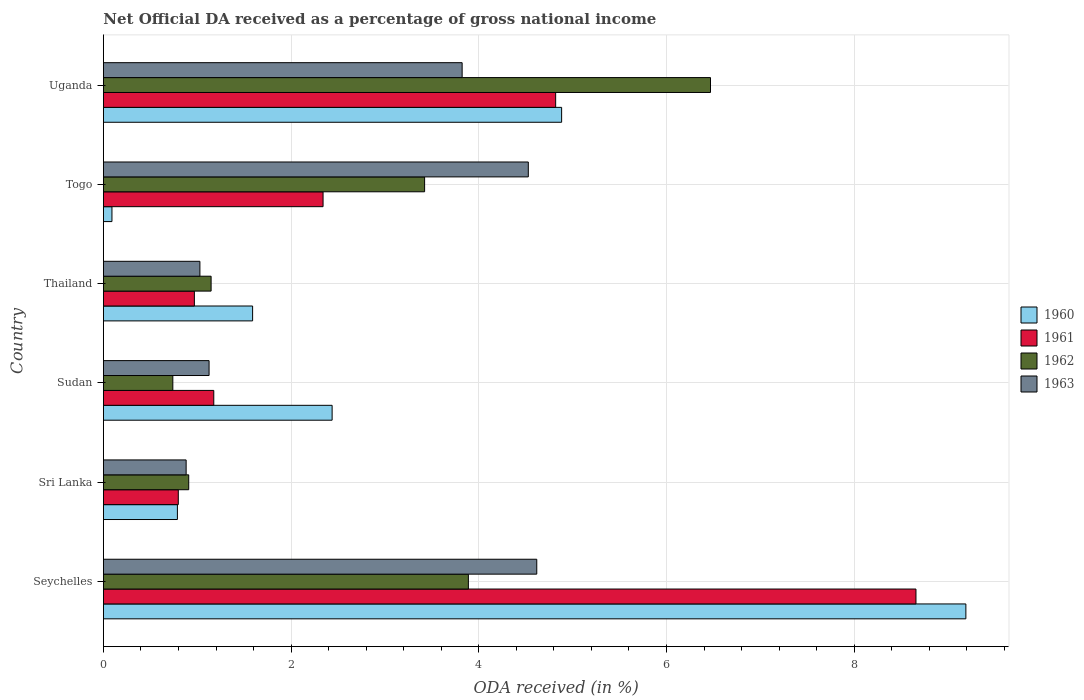Are the number of bars per tick equal to the number of legend labels?
Give a very brief answer. Yes. Are the number of bars on each tick of the Y-axis equal?
Provide a succinct answer. Yes. What is the label of the 2nd group of bars from the top?
Provide a short and direct response. Togo. What is the net official DA received in 1961 in Sri Lanka?
Your answer should be very brief. 0.8. Across all countries, what is the maximum net official DA received in 1960?
Offer a terse response. 9.19. Across all countries, what is the minimum net official DA received in 1960?
Your answer should be very brief. 0.09. In which country was the net official DA received in 1960 maximum?
Make the answer very short. Seychelles. In which country was the net official DA received in 1961 minimum?
Your answer should be very brief. Sri Lanka. What is the total net official DA received in 1962 in the graph?
Your response must be concise. 16.58. What is the difference between the net official DA received in 1961 in Togo and that in Uganda?
Give a very brief answer. -2.48. What is the difference between the net official DA received in 1962 in Sudan and the net official DA received in 1960 in Seychelles?
Your response must be concise. -8.45. What is the average net official DA received in 1960 per country?
Give a very brief answer. 3.16. What is the difference between the net official DA received in 1960 and net official DA received in 1963 in Seychelles?
Make the answer very short. 4.57. What is the ratio of the net official DA received in 1960 in Sudan to that in Thailand?
Ensure brevity in your answer.  1.53. What is the difference between the highest and the second highest net official DA received in 1962?
Keep it short and to the point. 2.58. What is the difference between the highest and the lowest net official DA received in 1963?
Offer a terse response. 3.74. Is the sum of the net official DA received in 1962 in Seychelles and Uganda greater than the maximum net official DA received in 1963 across all countries?
Offer a terse response. Yes. Is it the case that in every country, the sum of the net official DA received in 1962 and net official DA received in 1961 is greater than the sum of net official DA received in 1963 and net official DA received in 1960?
Offer a terse response. No. What does the 4th bar from the top in Seychelles represents?
Provide a succinct answer. 1960. What does the 2nd bar from the bottom in Sudan represents?
Your answer should be very brief. 1961. How many bars are there?
Your answer should be compact. 24. How many countries are there in the graph?
Your response must be concise. 6. What is the difference between two consecutive major ticks on the X-axis?
Offer a terse response. 2. Are the values on the major ticks of X-axis written in scientific E-notation?
Give a very brief answer. No. What is the title of the graph?
Offer a terse response. Net Official DA received as a percentage of gross national income. Does "2011" appear as one of the legend labels in the graph?
Provide a short and direct response. No. What is the label or title of the X-axis?
Your response must be concise. ODA received (in %). What is the label or title of the Y-axis?
Provide a succinct answer. Country. What is the ODA received (in %) of 1960 in Seychelles?
Give a very brief answer. 9.19. What is the ODA received (in %) of 1961 in Seychelles?
Your answer should be compact. 8.66. What is the ODA received (in %) in 1962 in Seychelles?
Ensure brevity in your answer.  3.89. What is the ODA received (in %) of 1963 in Seychelles?
Offer a very short reply. 4.62. What is the ODA received (in %) of 1960 in Sri Lanka?
Offer a very short reply. 0.79. What is the ODA received (in %) in 1961 in Sri Lanka?
Your response must be concise. 0.8. What is the ODA received (in %) in 1962 in Sri Lanka?
Provide a succinct answer. 0.91. What is the ODA received (in %) in 1963 in Sri Lanka?
Keep it short and to the point. 0.88. What is the ODA received (in %) in 1960 in Sudan?
Make the answer very short. 2.44. What is the ODA received (in %) in 1961 in Sudan?
Your response must be concise. 1.18. What is the ODA received (in %) in 1962 in Sudan?
Your response must be concise. 0.74. What is the ODA received (in %) of 1963 in Sudan?
Provide a short and direct response. 1.13. What is the ODA received (in %) in 1960 in Thailand?
Ensure brevity in your answer.  1.59. What is the ODA received (in %) in 1961 in Thailand?
Your answer should be very brief. 0.97. What is the ODA received (in %) in 1962 in Thailand?
Your response must be concise. 1.15. What is the ODA received (in %) in 1963 in Thailand?
Give a very brief answer. 1.03. What is the ODA received (in %) in 1960 in Togo?
Your response must be concise. 0.09. What is the ODA received (in %) in 1961 in Togo?
Ensure brevity in your answer.  2.34. What is the ODA received (in %) in 1962 in Togo?
Provide a short and direct response. 3.42. What is the ODA received (in %) in 1963 in Togo?
Your answer should be compact. 4.53. What is the ODA received (in %) of 1960 in Uganda?
Keep it short and to the point. 4.88. What is the ODA received (in %) in 1961 in Uganda?
Make the answer very short. 4.82. What is the ODA received (in %) of 1962 in Uganda?
Keep it short and to the point. 6.47. What is the ODA received (in %) in 1963 in Uganda?
Your answer should be very brief. 3.82. Across all countries, what is the maximum ODA received (in %) in 1960?
Your response must be concise. 9.19. Across all countries, what is the maximum ODA received (in %) of 1961?
Provide a short and direct response. 8.66. Across all countries, what is the maximum ODA received (in %) in 1962?
Your response must be concise. 6.47. Across all countries, what is the maximum ODA received (in %) in 1963?
Your answer should be compact. 4.62. Across all countries, what is the minimum ODA received (in %) of 1960?
Ensure brevity in your answer.  0.09. Across all countries, what is the minimum ODA received (in %) of 1961?
Your answer should be very brief. 0.8. Across all countries, what is the minimum ODA received (in %) of 1962?
Give a very brief answer. 0.74. Across all countries, what is the minimum ODA received (in %) in 1963?
Ensure brevity in your answer.  0.88. What is the total ODA received (in %) of 1960 in the graph?
Provide a short and direct response. 18.98. What is the total ODA received (in %) in 1961 in the graph?
Offer a terse response. 18.76. What is the total ODA received (in %) of 1962 in the graph?
Keep it short and to the point. 16.58. What is the total ODA received (in %) of 1963 in the graph?
Provide a short and direct response. 16. What is the difference between the ODA received (in %) in 1960 in Seychelles and that in Sri Lanka?
Make the answer very short. 8.4. What is the difference between the ODA received (in %) in 1961 in Seychelles and that in Sri Lanka?
Keep it short and to the point. 7.86. What is the difference between the ODA received (in %) in 1962 in Seychelles and that in Sri Lanka?
Keep it short and to the point. 2.98. What is the difference between the ODA received (in %) of 1963 in Seychelles and that in Sri Lanka?
Offer a very short reply. 3.74. What is the difference between the ODA received (in %) of 1960 in Seychelles and that in Sudan?
Your response must be concise. 6.75. What is the difference between the ODA received (in %) in 1961 in Seychelles and that in Sudan?
Offer a terse response. 7.48. What is the difference between the ODA received (in %) of 1962 in Seychelles and that in Sudan?
Your answer should be compact. 3.15. What is the difference between the ODA received (in %) in 1963 in Seychelles and that in Sudan?
Ensure brevity in your answer.  3.49. What is the difference between the ODA received (in %) of 1960 in Seychelles and that in Thailand?
Keep it short and to the point. 7.6. What is the difference between the ODA received (in %) in 1961 in Seychelles and that in Thailand?
Give a very brief answer. 7.69. What is the difference between the ODA received (in %) in 1962 in Seychelles and that in Thailand?
Provide a succinct answer. 2.74. What is the difference between the ODA received (in %) in 1963 in Seychelles and that in Thailand?
Your answer should be compact. 3.59. What is the difference between the ODA received (in %) in 1960 in Seychelles and that in Togo?
Your response must be concise. 9.1. What is the difference between the ODA received (in %) in 1961 in Seychelles and that in Togo?
Ensure brevity in your answer.  6.32. What is the difference between the ODA received (in %) of 1962 in Seychelles and that in Togo?
Give a very brief answer. 0.47. What is the difference between the ODA received (in %) of 1963 in Seychelles and that in Togo?
Ensure brevity in your answer.  0.09. What is the difference between the ODA received (in %) of 1960 in Seychelles and that in Uganda?
Keep it short and to the point. 4.31. What is the difference between the ODA received (in %) of 1961 in Seychelles and that in Uganda?
Offer a very short reply. 3.84. What is the difference between the ODA received (in %) of 1962 in Seychelles and that in Uganda?
Provide a short and direct response. -2.58. What is the difference between the ODA received (in %) of 1963 in Seychelles and that in Uganda?
Offer a terse response. 0.8. What is the difference between the ODA received (in %) of 1960 in Sri Lanka and that in Sudan?
Ensure brevity in your answer.  -1.65. What is the difference between the ODA received (in %) of 1961 in Sri Lanka and that in Sudan?
Your answer should be compact. -0.38. What is the difference between the ODA received (in %) in 1962 in Sri Lanka and that in Sudan?
Offer a terse response. 0.17. What is the difference between the ODA received (in %) of 1963 in Sri Lanka and that in Sudan?
Ensure brevity in your answer.  -0.24. What is the difference between the ODA received (in %) of 1960 in Sri Lanka and that in Thailand?
Make the answer very short. -0.8. What is the difference between the ODA received (in %) in 1961 in Sri Lanka and that in Thailand?
Keep it short and to the point. -0.17. What is the difference between the ODA received (in %) of 1962 in Sri Lanka and that in Thailand?
Make the answer very short. -0.24. What is the difference between the ODA received (in %) in 1963 in Sri Lanka and that in Thailand?
Your answer should be compact. -0.15. What is the difference between the ODA received (in %) of 1960 in Sri Lanka and that in Togo?
Ensure brevity in your answer.  0.7. What is the difference between the ODA received (in %) in 1961 in Sri Lanka and that in Togo?
Provide a succinct answer. -1.54. What is the difference between the ODA received (in %) in 1962 in Sri Lanka and that in Togo?
Keep it short and to the point. -2.51. What is the difference between the ODA received (in %) in 1963 in Sri Lanka and that in Togo?
Make the answer very short. -3.65. What is the difference between the ODA received (in %) of 1960 in Sri Lanka and that in Uganda?
Offer a terse response. -4.09. What is the difference between the ODA received (in %) in 1961 in Sri Lanka and that in Uganda?
Offer a very short reply. -4.02. What is the difference between the ODA received (in %) of 1962 in Sri Lanka and that in Uganda?
Provide a succinct answer. -5.56. What is the difference between the ODA received (in %) in 1963 in Sri Lanka and that in Uganda?
Your response must be concise. -2.94. What is the difference between the ODA received (in %) of 1960 in Sudan and that in Thailand?
Your response must be concise. 0.85. What is the difference between the ODA received (in %) of 1961 in Sudan and that in Thailand?
Offer a very short reply. 0.21. What is the difference between the ODA received (in %) of 1962 in Sudan and that in Thailand?
Give a very brief answer. -0.41. What is the difference between the ODA received (in %) of 1963 in Sudan and that in Thailand?
Offer a very short reply. 0.1. What is the difference between the ODA received (in %) in 1960 in Sudan and that in Togo?
Your answer should be compact. 2.35. What is the difference between the ODA received (in %) in 1961 in Sudan and that in Togo?
Provide a succinct answer. -1.16. What is the difference between the ODA received (in %) in 1962 in Sudan and that in Togo?
Give a very brief answer. -2.68. What is the difference between the ODA received (in %) of 1963 in Sudan and that in Togo?
Your answer should be compact. -3.4. What is the difference between the ODA received (in %) in 1960 in Sudan and that in Uganda?
Offer a very short reply. -2.45. What is the difference between the ODA received (in %) in 1961 in Sudan and that in Uganda?
Keep it short and to the point. -3.64. What is the difference between the ODA received (in %) of 1962 in Sudan and that in Uganda?
Your response must be concise. -5.73. What is the difference between the ODA received (in %) of 1963 in Sudan and that in Uganda?
Offer a very short reply. -2.7. What is the difference between the ODA received (in %) in 1960 in Thailand and that in Togo?
Your answer should be compact. 1.5. What is the difference between the ODA received (in %) of 1961 in Thailand and that in Togo?
Keep it short and to the point. -1.37. What is the difference between the ODA received (in %) of 1962 in Thailand and that in Togo?
Offer a terse response. -2.27. What is the difference between the ODA received (in %) in 1963 in Thailand and that in Togo?
Keep it short and to the point. -3.5. What is the difference between the ODA received (in %) of 1960 in Thailand and that in Uganda?
Offer a very short reply. -3.29. What is the difference between the ODA received (in %) of 1961 in Thailand and that in Uganda?
Provide a succinct answer. -3.85. What is the difference between the ODA received (in %) of 1962 in Thailand and that in Uganda?
Ensure brevity in your answer.  -5.32. What is the difference between the ODA received (in %) of 1963 in Thailand and that in Uganda?
Offer a terse response. -2.79. What is the difference between the ODA received (in %) in 1960 in Togo and that in Uganda?
Your answer should be very brief. -4.79. What is the difference between the ODA received (in %) of 1961 in Togo and that in Uganda?
Keep it short and to the point. -2.48. What is the difference between the ODA received (in %) of 1962 in Togo and that in Uganda?
Ensure brevity in your answer.  -3.05. What is the difference between the ODA received (in %) of 1963 in Togo and that in Uganda?
Your answer should be compact. 0.7. What is the difference between the ODA received (in %) in 1960 in Seychelles and the ODA received (in %) in 1961 in Sri Lanka?
Ensure brevity in your answer.  8.39. What is the difference between the ODA received (in %) in 1960 in Seychelles and the ODA received (in %) in 1962 in Sri Lanka?
Ensure brevity in your answer.  8.28. What is the difference between the ODA received (in %) in 1960 in Seychelles and the ODA received (in %) in 1963 in Sri Lanka?
Offer a very short reply. 8.31. What is the difference between the ODA received (in %) in 1961 in Seychelles and the ODA received (in %) in 1962 in Sri Lanka?
Provide a succinct answer. 7.75. What is the difference between the ODA received (in %) of 1961 in Seychelles and the ODA received (in %) of 1963 in Sri Lanka?
Provide a succinct answer. 7.78. What is the difference between the ODA received (in %) in 1962 in Seychelles and the ODA received (in %) in 1963 in Sri Lanka?
Your answer should be very brief. 3.01. What is the difference between the ODA received (in %) of 1960 in Seychelles and the ODA received (in %) of 1961 in Sudan?
Give a very brief answer. 8.01. What is the difference between the ODA received (in %) in 1960 in Seychelles and the ODA received (in %) in 1962 in Sudan?
Your answer should be compact. 8.45. What is the difference between the ODA received (in %) of 1960 in Seychelles and the ODA received (in %) of 1963 in Sudan?
Your answer should be very brief. 8.06. What is the difference between the ODA received (in %) of 1961 in Seychelles and the ODA received (in %) of 1962 in Sudan?
Keep it short and to the point. 7.92. What is the difference between the ODA received (in %) of 1961 in Seychelles and the ODA received (in %) of 1963 in Sudan?
Make the answer very short. 7.53. What is the difference between the ODA received (in %) of 1962 in Seychelles and the ODA received (in %) of 1963 in Sudan?
Provide a succinct answer. 2.76. What is the difference between the ODA received (in %) of 1960 in Seychelles and the ODA received (in %) of 1961 in Thailand?
Offer a terse response. 8.22. What is the difference between the ODA received (in %) of 1960 in Seychelles and the ODA received (in %) of 1962 in Thailand?
Your answer should be very brief. 8.04. What is the difference between the ODA received (in %) of 1960 in Seychelles and the ODA received (in %) of 1963 in Thailand?
Your response must be concise. 8.16. What is the difference between the ODA received (in %) in 1961 in Seychelles and the ODA received (in %) in 1962 in Thailand?
Keep it short and to the point. 7.51. What is the difference between the ODA received (in %) of 1961 in Seychelles and the ODA received (in %) of 1963 in Thailand?
Offer a very short reply. 7.63. What is the difference between the ODA received (in %) in 1962 in Seychelles and the ODA received (in %) in 1963 in Thailand?
Ensure brevity in your answer.  2.86. What is the difference between the ODA received (in %) in 1960 in Seychelles and the ODA received (in %) in 1961 in Togo?
Offer a terse response. 6.85. What is the difference between the ODA received (in %) of 1960 in Seychelles and the ODA received (in %) of 1962 in Togo?
Your answer should be compact. 5.77. What is the difference between the ODA received (in %) of 1960 in Seychelles and the ODA received (in %) of 1963 in Togo?
Ensure brevity in your answer.  4.66. What is the difference between the ODA received (in %) of 1961 in Seychelles and the ODA received (in %) of 1962 in Togo?
Keep it short and to the point. 5.24. What is the difference between the ODA received (in %) of 1961 in Seychelles and the ODA received (in %) of 1963 in Togo?
Provide a short and direct response. 4.13. What is the difference between the ODA received (in %) in 1962 in Seychelles and the ODA received (in %) in 1963 in Togo?
Offer a very short reply. -0.64. What is the difference between the ODA received (in %) in 1960 in Seychelles and the ODA received (in %) in 1961 in Uganda?
Keep it short and to the point. 4.37. What is the difference between the ODA received (in %) of 1960 in Seychelles and the ODA received (in %) of 1962 in Uganda?
Provide a succinct answer. 2.72. What is the difference between the ODA received (in %) of 1960 in Seychelles and the ODA received (in %) of 1963 in Uganda?
Provide a succinct answer. 5.37. What is the difference between the ODA received (in %) in 1961 in Seychelles and the ODA received (in %) in 1962 in Uganda?
Your response must be concise. 2.19. What is the difference between the ODA received (in %) in 1961 in Seychelles and the ODA received (in %) in 1963 in Uganda?
Ensure brevity in your answer.  4.84. What is the difference between the ODA received (in %) in 1962 in Seychelles and the ODA received (in %) in 1963 in Uganda?
Your answer should be very brief. 0.07. What is the difference between the ODA received (in %) in 1960 in Sri Lanka and the ODA received (in %) in 1961 in Sudan?
Offer a very short reply. -0.39. What is the difference between the ODA received (in %) of 1960 in Sri Lanka and the ODA received (in %) of 1962 in Sudan?
Make the answer very short. 0.05. What is the difference between the ODA received (in %) in 1960 in Sri Lanka and the ODA received (in %) in 1963 in Sudan?
Your answer should be compact. -0.34. What is the difference between the ODA received (in %) of 1961 in Sri Lanka and the ODA received (in %) of 1962 in Sudan?
Keep it short and to the point. 0.06. What is the difference between the ODA received (in %) of 1961 in Sri Lanka and the ODA received (in %) of 1963 in Sudan?
Offer a very short reply. -0.33. What is the difference between the ODA received (in %) of 1962 in Sri Lanka and the ODA received (in %) of 1963 in Sudan?
Provide a short and direct response. -0.22. What is the difference between the ODA received (in %) of 1960 in Sri Lanka and the ODA received (in %) of 1961 in Thailand?
Your response must be concise. -0.18. What is the difference between the ODA received (in %) in 1960 in Sri Lanka and the ODA received (in %) in 1962 in Thailand?
Offer a very short reply. -0.36. What is the difference between the ODA received (in %) in 1960 in Sri Lanka and the ODA received (in %) in 1963 in Thailand?
Your answer should be compact. -0.24. What is the difference between the ODA received (in %) of 1961 in Sri Lanka and the ODA received (in %) of 1962 in Thailand?
Provide a succinct answer. -0.35. What is the difference between the ODA received (in %) in 1961 in Sri Lanka and the ODA received (in %) in 1963 in Thailand?
Offer a very short reply. -0.23. What is the difference between the ODA received (in %) in 1962 in Sri Lanka and the ODA received (in %) in 1963 in Thailand?
Ensure brevity in your answer.  -0.12. What is the difference between the ODA received (in %) of 1960 in Sri Lanka and the ODA received (in %) of 1961 in Togo?
Offer a terse response. -1.55. What is the difference between the ODA received (in %) of 1960 in Sri Lanka and the ODA received (in %) of 1962 in Togo?
Ensure brevity in your answer.  -2.63. What is the difference between the ODA received (in %) of 1960 in Sri Lanka and the ODA received (in %) of 1963 in Togo?
Keep it short and to the point. -3.74. What is the difference between the ODA received (in %) in 1961 in Sri Lanka and the ODA received (in %) in 1962 in Togo?
Offer a very short reply. -2.62. What is the difference between the ODA received (in %) of 1961 in Sri Lanka and the ODA received (in %) of 1963 in Togo?
Your response must be concise. -3.73. What is the difference between the ODA received (in %) of 1962 in Sri Lanka and the ODA received (in %) of 1963 in Togo?
Your answer should be very brief. -3.62. What is the difference between the ODA received (in %) of 1960 in Sri Lanka and the ODA received (in %) of 1961 in Uganda?
Keep it short and to the point. -4.03. What is the difference between the ODA received (in %) of 1960 in Sri Lanka and the ODA received (in %) of 1962 in Uganda?
Your response must be concise. -5.68. What is the difference between the ODA received (in %) in 1960 in Sri Lanka and the ODA received (in %) in 1963 in Uganda?
Offer a terse response. -3.03. What is the difference between the ODA received (in %) of 1961 in Sri Lanka and the ODA received (in %) of 1962 in Uganda?
Provide a succinct answer. -5.67. What is the difference between the ODA received (in %) in 1961 in Sri Lanka and the ODA received (in %) in 1963 in Uganda?
Make the answer very short. -3.02. What is the difference between the ODA received (in %) in 1962 in Sri Lanka and the ODA received (in %) in 1963 in Uganda?
Provide a short and direct response. -2.91. What is the difference between the ODA received (in %) of 1960 in Sudan and the ODA received (in %) of 1961 in Thailand?
Make the answer very short. 1.47. What is the difference between the ODA received (in %) of 1960 in Sudan and the ODA received (in %) of 1962 in Thailand?
Make the answer very short. 1.29. What is the difference between the ODA received (in %) in 1960 in Sudan and the ODA received (in %) in 1963 in Thailand?
Keep it short and to the point. 1.41. What is the difference between the ODA received (in %) of 1961 in Sudan and the ODA received (in %) of 1962 in Thailand?
Offer a terse response. 0.03. What is the difference between the ODA received (in %) in 1961 in Sudan and the ODA received (in %) in 1963 in Thailand?
Give a very brief answer. 0.15. What is the difference between the ODA received (in %) in 1962 in Sudan and the ODA received (in %) in 1963 in Thailand?
Your answer should be compact. -0.29. What is the difference between the ODA received (in %) of 1960 in Sudan and the ODA received (in %) of 1961 in Togo?
Your answer should be very brief. 0.1. What is the difference between the ODA received (in %) of 1960 in Sudan and the ODA received (in %) of 1962 in Togo?
Your answer should be compact. -0.99. What is the difference between the ODA received (in %) in 1960 in Sudan and the ODA received (in %) in 1963 in Togo?
Give a very brief answer. -2.09. What is the difference between the ODA received (in %) of 1961 in Sudan and the ODA received (in %) of 1962 in Togo?
Your answer should be very brief. -2.25. What is the difference between the ODA received (in %) in 1961 in Sudan and the ODA received (in %) in 1963 in Togo?
Provide a short and direct response. -3.35. What is the difference between the ODA received (in %) of 1962 in Sudan and the ODA received (in %) of 1963 in Togo?
Offer a very short reply. -3.79. What is the difference between the ODA received (in %) in 1960 in Sudan and the ODA received (in %) in 1961 in Uganda?
Your answer should be very brief. -2.38. What is the difference between the ODA received (in %) of 1960 in Sudan and the ODA received (in %) of 1962 in Uganda?
Keep it short and to the point. -4.03. What is the difference between the ODA received (in %) in 1960 in Sudan and the ODA received (in %) in 1963 in Uganda?
Give a very brief answer. -1.39. What is the difference between the ODA received (in %) in 1961 in Sudan and the ODA received (in %) in 1962 in Uganda?
Your answer should be compact. -5.29. What is the difference between the ODA received (in %) of 1961 in Sudan and the ODA received (in %) of 1963 in Uganda?
Give a very brief answer. -2.65. What is the difference between the ODA received (in %) in 1962 in Sudan and the ODA received (in %) in 1963 in Uganda?
Provide a short and direct response. -3.08. What is the difference between the ODA received (in %) in 1960 in Thailand and the ODA received (in %) in 1961 in Togo?
Keep it short and to the point. -0.75. What is the difference between the ODA received (in %) in 1960 in Thailand and the ODA received (in %) in 1962 in Togo?
Offer a terse response. -1.83. What is the difference between the ODA received (in %) of 1960 in Thailand and the ODA received (in %) of 1963 in Togo?
Keep it short and to the point. -2.94. What is the difference between the ODA received (in %) in 1961 in Thailand and the ODA received (in %) in 1962 in Togo?
Offer a very short reply. -2.45. What is the difference between the ODA received (in %) in 1961 in Thailand and the ODA received (in %) in 1963 in Togo?
Offer a very short reply. -3.56. What is the difference between the ODA received (in %) of 1962 in Thailand and the ODA received (in %) of 1963 in Togo?
Keep it short and to the point. -3.38. What is the difference between the ODA received (in %) in 1960 in Thailand and the ODA received (in %) in 1961 in Uganda?
Keep it short and to the point. -3.23. What is the difference between the ODA received (in %) in 1960 in Thailand and the ODA received (in %) in 1962 in Uganda?
Offer a very short reply. -4.88. What is the difference between the ODA received (in %) of 1960 in Thailand and the ODA received (in %) of 1963 in Uganda?
Provide a short and direct response. -2.23. What is the difference between the ODA received (in %) in 1961 in Thailand and the ODA received (in %) in 1962 in Uganda?
Ensure brevity in your answer.  -5.5. What is the difference between the ODA received (in %) in 1961 in Thailand and the ODA received (in %) in 1963 in Uganda?
Ensure brevity in your answer.  -2.85. What is the difference between the ODA received (in %) of 1962 in Thailand and the ODA received (in %) of 1963 in Uganda?
Make the answer very short. -2.67. What is the difference between the ODA received (in %) of 1960 in Togo and the ODA received (in %) of 1961 in Uganda?
Give a very brief answer. -4.73. What is the difference between the ODA received (in %) of 1960 in Togo and the ODA received (in %) of 1962 in Uganda?
Offer a terse response. -6.38. What is the difference between the ODA received (in %) of 1960 in Togo and the ODA received (in %) of 1963 in Uganda?
Ensure brevity in your answer.  -3.73. What is the difference between the ODA received (in %) of 1961 in Togo and the ODA received (in %) of 1962 in Uganda?
Ensure brevity in your answer.  -4.13. What is the difference between the ODA received (in %) in 1961 in Togo and the ODA received (in %) in 1963 in Uganda?
Provide a short and direct response. -1.48. What is the difference between the ODA received (in %) in 1962 in Togo and the ODA received (in %) in 1963 in Uganda?
Ensure brevity in your answer.  -0.4. What is the average ODA received (in %) of 1960 per country?
Offer a very short reply. 3.16. What is the average ODA received (in %) in 1961 per country?
Make the answer very short. 3.13. What is the average ODA received (in %) in 1962 per country?
Keep it short and to the point. 2.76. What is the average ODA received (in %) of 1963 per country?
Provide a succinct answer. 2.67. What is the difference between the ODA received (in %) of 1960 and ODA received (in %) of 1961 in Seychelles?
Make the answer very short. 0.53. What is the difference between the ODA received (in %) in 1960 and ODA received (in %) in 1962 in Seychelles?
Ensure brevity in your answer.  5.3. What is the difference between the ODA received (in %) of 1960 and ODA received (in %) of 1963 in Seychelles?
Your response must be concise. 4.57. What is the difference between the ODA received (in %) in 1961 and ODA received (in %) in 1962 in Seychelles?
Your response must be concise. 4.77. What is the difference between the ODA received (in %) of 1961 and ODA received (in %) of 1963 in Seychelles?
Give a very brief answer. 4.04. What is the difference between the ODA received (in %) of 1962 and ODA received (in %) of 1963 in Seychelles?
Make the answer very short. -0.73. What is the difference between the ODA received (in %) in 1960 and ODA received (in %) in 1961 in Sri Lanka?
Provide a short and direct response. -0.01. What is the difference between the ODA received (in %) of 1960 and ODA received (in %) of 1962 in Sri Lanka?
Your response must be concise. -0.12. What is the difference between the ODA received (in %) in 1960 and ODA received (in %) in 1963 in Sri Lanka?
Keep it short and to the point. -0.09. What is the difference between the ODA received (in %) in 1961 and ODA received (in %) in 1962 in Sri Lanka?
Your answer should be very brief. -0.11. What is the difference between the ODA received (in %) in 1961 and ODA received (in %) in 1963 in Sri Lanka?
Offer a terse response. -0.08. What is the difference between the ODA received (in %) in 1962 and ODA received (in %) in 1963 in Sri Lanka?
Ensure brevity in your answer.  0.03. What is the difference between the ODA received (in %) in 1960 and ODA received (in %) in 1961 in Sudan?
Your answer should be compact. 1.26. What is the difference between the ODA received (in %) in 1960 and ODA received (in %) in 1962 in Sudan?
Keep it short and to the point. 1.7. What is the difference between the ODA received (in %) of 1960 and ODA received (in %) of 1963 in Sudan?
Your response must be concise. 1.31. What is the difference between the ODA received (in %) of 1961 and ODA received (in %) of 1962 in Sudan?
Make the answer very short. 0.44. What is the difference between the ODA received (in %) in 1961 and ODA received (in %) in 1963 in Sudan?
Your response must be concise. 0.05. What is the difference between the ODA received (in %) in 1962 and ODA received (in %) in 1963 in Sudan?
Your response must be concise. -0.39. What is the difference between the ODA received (in %) in 1960 and ODA received (in %) in 1961 in Thailand?
Give a very brief answer. 0.62. What is the difference between the ODA received (in %) in 1960 and ODA received (in %) in 1962 in Thailand?
Ensure brevity in your answer.  0.44. What is the difference between the ODA received (in %) of 1960 and ODA received (in %) of 1963 in Thailand?
Provide a succinct answer. 0.56. What is the difference between the ODA received (in %) in 1961 and ODA received (in %) in 1962 in Thailand?
Provide a succinct answer. -0.18. What is the difference between the ODA received (in %) of 1961 and ODA received (in %) of 1963 in Thailand?
Give a very brief answer. -0.06. What is the difference between the ODA received (in %) of 1962 and ODA received (in %) of 1963 in Thailand?
Provide a short and direct response. 0.12. What is the difference between the ODA received (in %) of 1960 and ODA received (in %) of 1961 in Togo?
Your answer should be compact. -2.25. What is the difference between the ODA received (in %) in 1960 and ODA received (in %) in 1962 in Togo?
Your answer should be compact. -3.33. What is the difference between the ODA received (in %) of 1960 and ODA received (in %) of 1963 in Togo?
Your answer should be compact. -4.44. What is the difference between the ODA received (in %) of 1961 and ODA received (in %) of 1962 in Togo?
Ensure brevity in your answer.  -1.08. What is the difference between the ODA received (in %) of 1961 and ODA received (in %) of 1963 in Togo?
Offer a very short reply. -2.19. What is the difference between the ODA received (in %) of 1962 and ODA received (in %) of 1963 in Togo?
Offer a terse response. -1.1. What is the difference between the ODA received (in %) in 1960 and ODA received (in %) in 1961 in Uganda?
Offer a terse response. 0.06. What is the difference between the ODA received (in %) of 1960 and ODA received (in %) of 1962 in Uganda?
Make the answer very short. -1.59. What is the difference between the ODA received (in %) of 1960 and ODA received (in %) of 1963 in Uganda?
Offer a terse response. 1.06. What is the difference between the ODA received (in %) in 1961 and ODA received (in %) in 1962 in Uganda?
Offer a terse response. -1.65. What is the difference between the ODA received (in %) in 1961 and ODA received (in %) in 1963 in Uganda?
Provide a succinct answer. 1. What is the difference between the ODA received (in %) of 1962 and ODA received (in %) of 1963 in Uganda?
Give a very brief answer. 2.65. What is the ratio of the ODA received (in %) of 1960 in Seychelles to that in Sri Lanka?
Offer a terse response. 11.65. What is the ratio of the ODA received (in %) of 1961 in Seychelles to that in Sri Lanka?
Keep it short and to the point. 10.85. What is the ratio of the ODA received (in %) in 1962 in Seychelles to that in Sri Lanka?
Your answer should be compact. 4.28. What is the ratio of the ODA received (in %) in 1963 in Seychelles to that in Sri Lanka?
Make the answer very short. 5.24. What is the ratio of the ODA received (in %) in 1960 in Seychelles to that in Sudan?
Make the answer very short. 3.77. What is the ratio of the ODA received (in %) of 1961 in Seychelles to that in Sudan?
Make the answer very short. 7.36. What is the ratio of the ODA received (in %) of 1962 in Seychelles to that in Sudan?
Provide a short and direct response. 5.26. What is the ratio of the ODA received (in %) in 1963 in Seychelles to that in Sudan?
Your answer should be very brief. 4.1. What is the ratio of the ODA received (in %) of 1960 in Seychelles to that in Thailand?
Provide a succinct answer. 5.78. What is the ratio of the ODA received (in %) in 1961 in Seychelles to that in Thailand?
Offer a terse response. 8.93. What is the ratio of the ODA received (in %) in 1962 in Seychelles to that in Thailand?
Give a very brief answer. 3.39. What is the ratio of the ODA received (in %) in 1963 in Seychelles to that in Thailand?
Keep it short and to the point. 4.49. What is the ratio of the ODA received (in %) of 1960 in Seychelles to that in Togo?
Make the answer very short. 100.8. What is the ratio of the ODA received (in %) in 1961 in Seychelles to that in Togo?
Offer a very short reply. 3.7. What is the ratio of the ODA received (in %) in 1962 in Seychelles to that in Togo?
Give a very brief answer. 1.14. What is the ratio of the ODA received (in %) of 1963 in Seychelles to that in Togo?
Your response must be concise. 1.02. What is the ratio of the ODA received (in %) of 1960 in Seychelles to that in Uganda?
Make the answer very short. 1.88. What is the ratio of the ODA received (in %) of 1961 in Seychelles to that in Uganda?
Offer a terse response. 1.8. What is the ratio of the ODA received (in %) in 1962 in Seychelles to that in Uganda?
Your answer should be very brief. 0.6. What is the ratio of the ODA received (in %) of 1963 in Seychelles to that in Uganda?
Offer a terse response. 1.21. What is the ratio of the ODA received (in %) of 1960 in Sri Lanka to that in Sudan?
Your answer should be compact. 0.32. What is the ratio of the ODA received (in %) in 1961 in Sri Lanka to that in Sudan?
Give a very brief answer. 0.68. What is the ratio of the ODA received (in %) in 1962 in Sri Lanka to that in Sudan?
Your answer should be compact. 1.23. What is the ratio of the ODA received (in %) in 1963 in Sri Lanka to that in Sudan?
Give a very brief answer. 0.78. What is the ratio of the ODA received (in %) in 1960 in Sri Lanka to that in Thailand?
Make the answer very short. 0.5. What is the ratio of the ODA received (in %) of 1961 in Sri Lanka to that in Thailand?
Offer a very short reply. 0.82. What is the ratio of the ODA received (in %) in 1962 in Sri Lanka to that in Thailand?
Provide a succinct answer. 0.79. What is the ratio of the ODA received (in %) of 1963 in Sri Lanka to that in Thailand?
Give a very brief answer. 0.86. What is the ratio of the ODA received (in %) of 1960 in Sri Lanka to that in Togo?
Your answer should be very brief. 8.65. What is the ratio of the ODA received (in %) of 1961 in Sri Lanka to that in Togo?
Your answer should be very brief. 0.34. What is the ratio of the ODA received (in %) in 1962 in Sri Lanka to that in Togo?
Your answer should be compact. 0.27. What is the ratio of the ODA received (in %) in 1963 in Sri Lanka to that in Togo?
Offer a terse response. 0.19. What is the ratio of the ODA received (in %) in 1960 in Sri Lanka to that in Uganda?
Your answer should be very brief. 0.16. What is the ratio of the ODA received (in %) in 1961 in Sri Lanka to that in Uganda?
Give a very brief answer. 0.17. What is the ratio of the ODA received (in %) in 1962 in Sri Lanka to that in Uganda?
Offer a terse response. 0.14. What is the ratio of the ODA received (in %) in 1963 in Sri Lanka to that in Uganda?
Make the answer very short. 0.23. What is the ratio of the ODA received (in %) of 1960 in Sudan to that in Thailand?
Provide a short and direct response. 1.53. What is the ratio of the ODA received (in %) in 1961 in Sudan to that in Thailand?
Provide a succinct answer. 1.21. What is the ratio of the ODA received (in %) of 1962 in Sudan to that in Thailand?
Offer a terse response. 0.64. What is the ratio of the ODA received (in %) of 1963 in Sudan to that in Thailand?
Offer a very short reply. 1.1. What is the ratio of the ODA received (in %) of 1960 in Sudan to that in Togo?
Your answer should be very brief. 26.73. What is the ratio of the ODA received (in %) in 1961 in Sudan to that in Togo?
Make the answer very short. 0.5. What is the ratio of the ODA received (in %) in 1962 in Sudan to that in Togo?
Offer a terse response. 0.22. What is the ratio of the ODA received (in %) of 1963 in Sudan to that in Togo?
Offer a very short reply. 0.25. What is the ratio of the ODA received (in %) of 1960 in Sudan to that in Uganda?
Your answer should be compact. 0.5. What is the ratio of the ODA received (in %) of 1961 in Sudan to that in Uganda?
Offer a very short reply. 0.24. What is the ratio of the ODA received (in %) in 1962 in Sudan to that in Uganda?
Offer a terse response. 0.11. What is the ratio of the ODA received (in %) of 1963 in Sudan to that in Uganda?
Give a very brief answer. 0.29. What is the ratio of the ODA received (in %) in 1960 in Thailand to that in Togo?
Your answer should be compact. 17.44. What is the ratio of the ODA received (in %) in 1961 in Thailand to that in Togo?
Your response must be concise. 0.41. What is the ratio of the ODA received (in %) in 1962 in Thailand to that in Togo?
Your answer should be compact. 0.34. What is the ratio of the ODA received (in %) of 1963 in Thailand to that in Togo?
Give a very brief answer. 0.23. What is the ratio of the ODA received (in %) in 1960 in Thailand to that in Uganda?
Make the answer very short. 0.33. What is the ratio of the ODA received (in %) of 1961 in Thailand to that in Uganda?
Make the answer very short. 0.2. What is the ratio of the ODA received (in %) of 1962 in Thailand to that in Uganda?
Make the answer very short. 0.18. What is the ratio of the ODA received (in %) in 1963 in Thailand to that in Uganda?
Keep it short and to the point. 0.27. What is the ratio of the ODA received (in %) of 1960 in Togo to that in Uganda?
Offer a terse response. 0.02. What is the ratio of the ODA received (in %) of 1961 in Togo to that in Uganda?
Give a very brief answer. 0.49. What is the ratio of the ODA received (in %) of 1962 in Togo to that in Uganda?
Keep it short and to the point. 0.53. What is the ratio of the ODA received (in %) in 1963 in Togo to that in Uganda?
Offer a terse response. 1.18. What is the difference between the highest and the second highest ODA received (in %) of 1960?
Provide a succinct answer. 4.31. What is the difference between the highest and the second highest ODA received (in %) in 1961?
Your response must be concise. 3.84. What is the difference between the highest and the second highest ODA received (in %) in 1962?
Provide a short and direct response. 2.58. What is the difference between the highest and the second highest ODA received (in %) of 1963?
Your answer should be very brief. 0.09. What is the difference between the highest and the lowest ODA received (in %) of 1960?
Offer a terse response. 9.1. What is the difference between the highest and the lowest ODA received (in %) in 1961?
Your answer should be very brief. 7.86. What is the difference between the highest and the lowest ODA received (in %) in 1962?
Offer a terse response. 5.73. What is the difference between the highest and the lowest ODA received (in %) in 1963?
Make the answer very short. 3.74. 